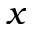Convert formula to latex. <formula><loc_0><loc_0><loc_500><loc_500>x</formula> 